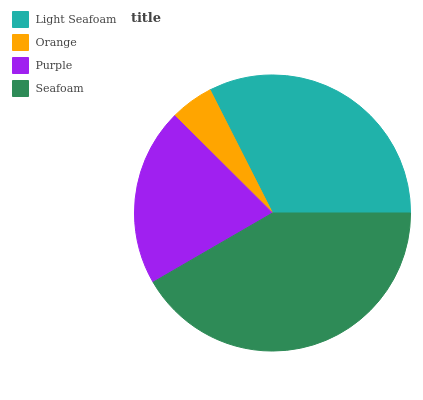Is Orange the minimum?
Answer yes or no. Yes. Is Seafoam the maximum?
Answer yes or no. Yes. Is Purple the minimum?
Answer yes or no. No. Is Purple the maximum?
Answer yes or no. No. Is Purple greater than Orange?
Answer yes or no. Yes. Is Orange less than Purple?
Answer yes or no. Yes. Is Orange greater than Purple?
Answer yes or no. No. Is Purple less than Orange?
Answer yes or no. No. Is Light Seafoam the high median?
Answer yes or no. Yes. Is Purple the low median?
Answer yes or no. Yes. Is Orange the high median?
Answer yes or no. No. Is Orange the low median?
Answer yes or no. No. 